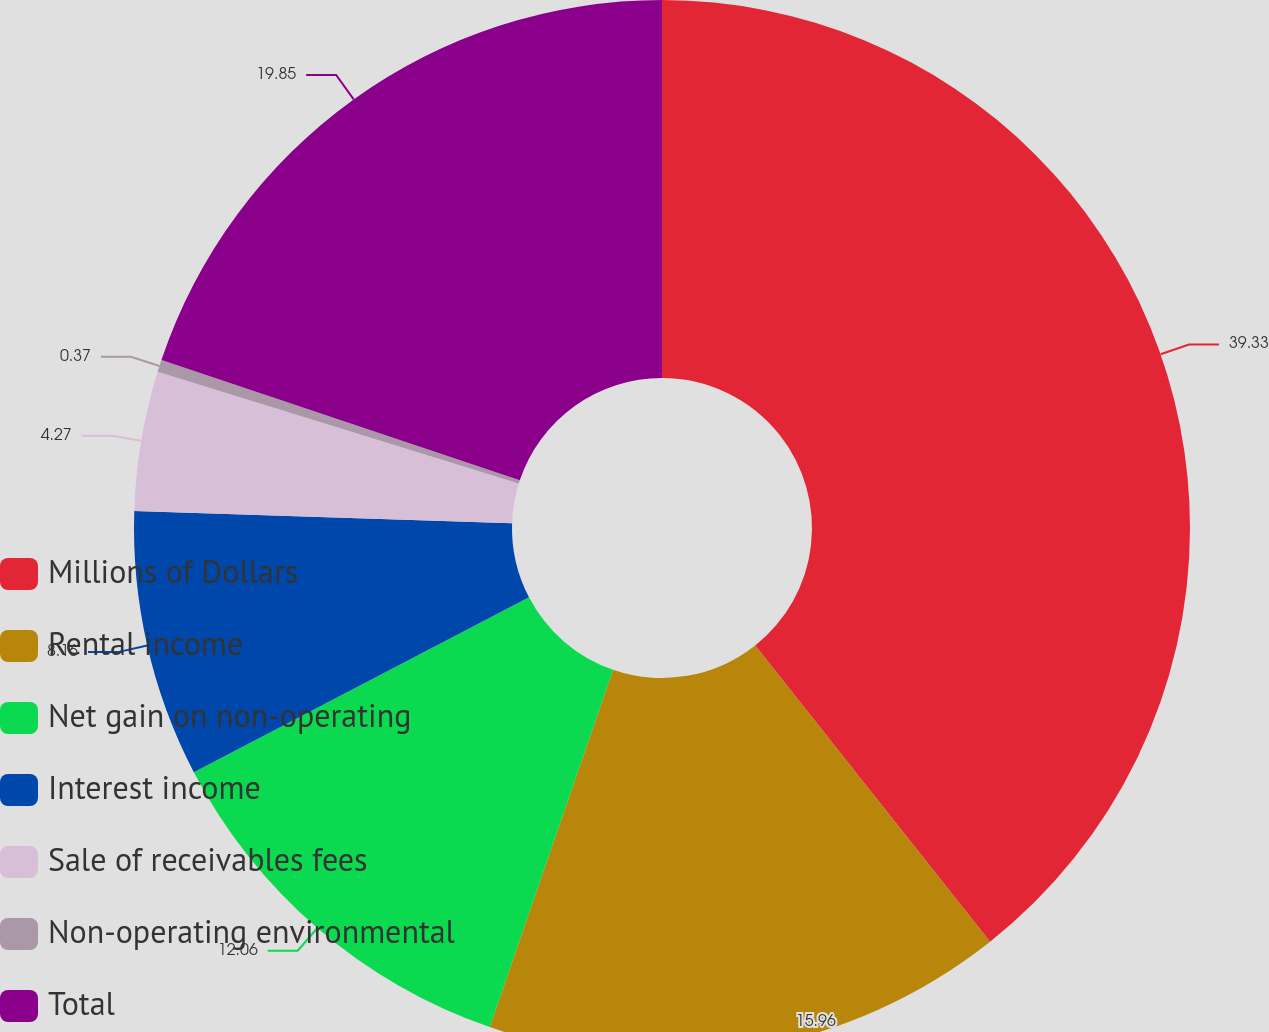Convert chart to OTSL. <chart><loc_0><loc_0><loc_500><loc_500><pie_chart><fcel>Millions of Dollars<fcel>Rental income<fcel>Net gain on non-operating<fcel>Interest income<fcel>Sale of receivables fees<fcel>Non-operating environmental<fcel>Total<nl><fcel>39.33%<fcel>15.96%<fcel>12.06%<fcel>8.16%<fcel>4.27%<fcel>0.37%<fcel>19.85%<nl></chart> 